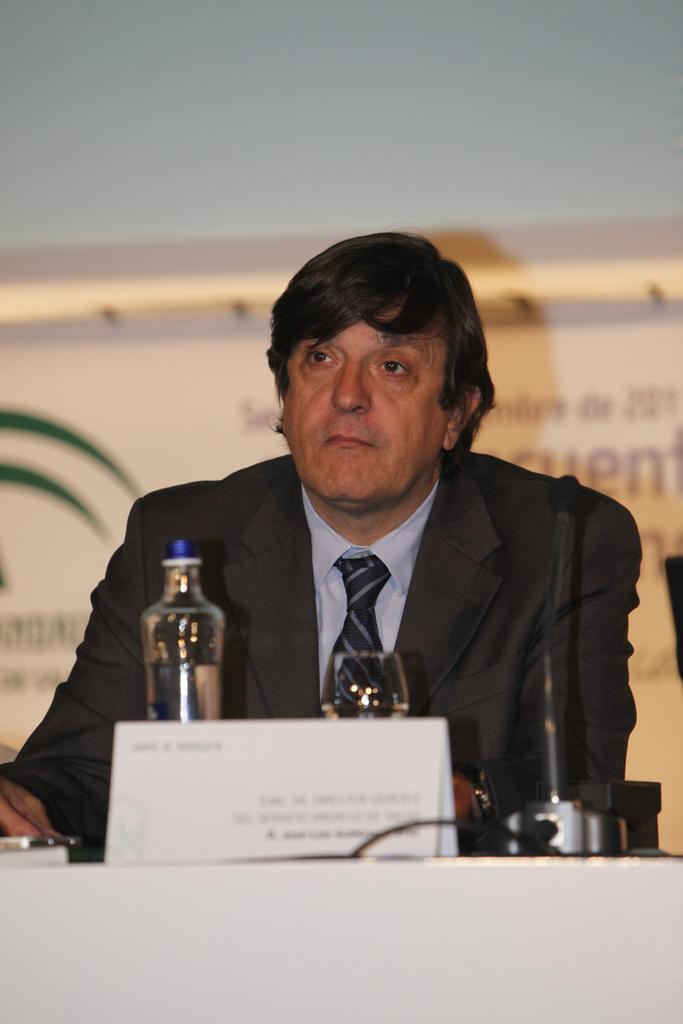What is the man in the image doing? The man is sitting on a chair in the image. What is in front of the man? There is a table in front of the man. What items can be seen on the table? A water bottle, glasses, and a microphone are present on the table. What can be seen in the background of the image? There is a wall and a banner in the background. What type of soda is the man drinking in the image? There is no soda present in the image; only a water bottle is visible on the table. What angle is the grandmother sitting at in the image? There is no grandmother present in the image. 